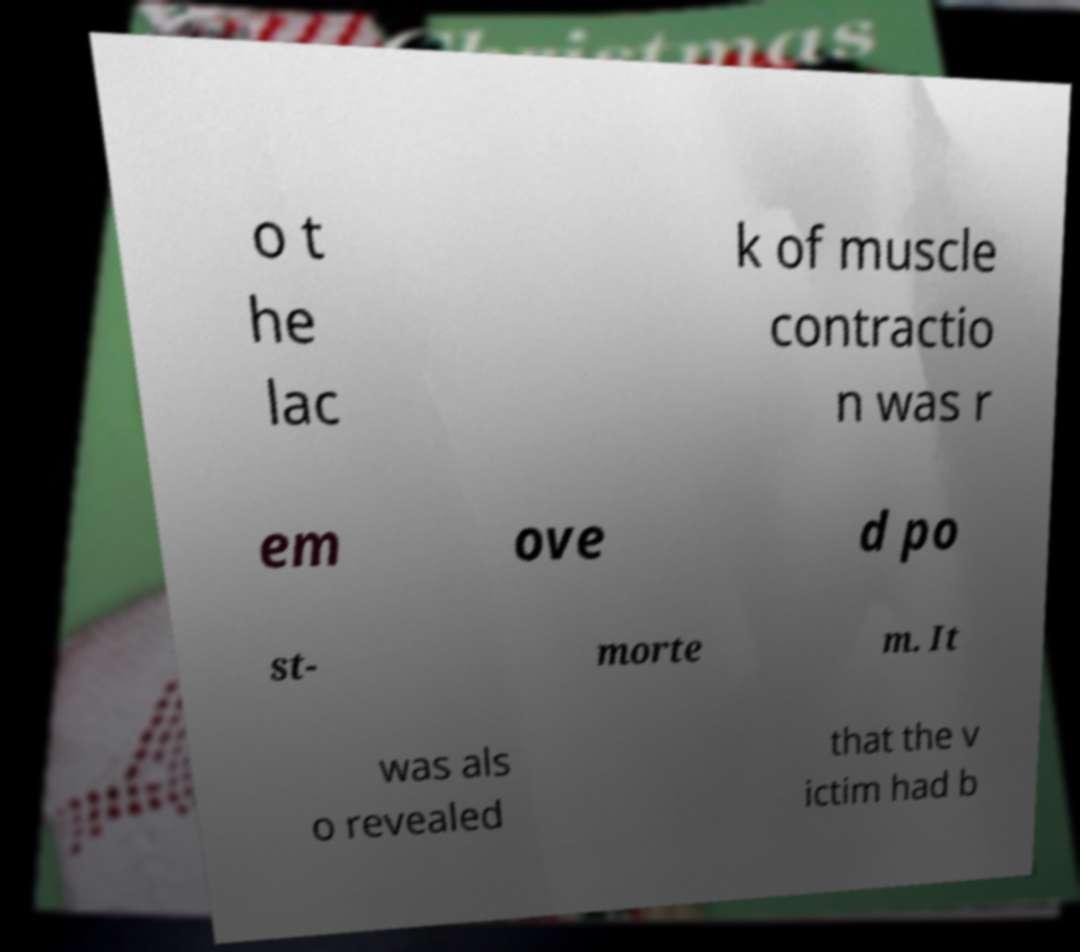Could you extract and type out the text from this image? o t he lac k of muscle contractio n was r em ove d po st- morte m. It was als o revealed that the v ictim had b 